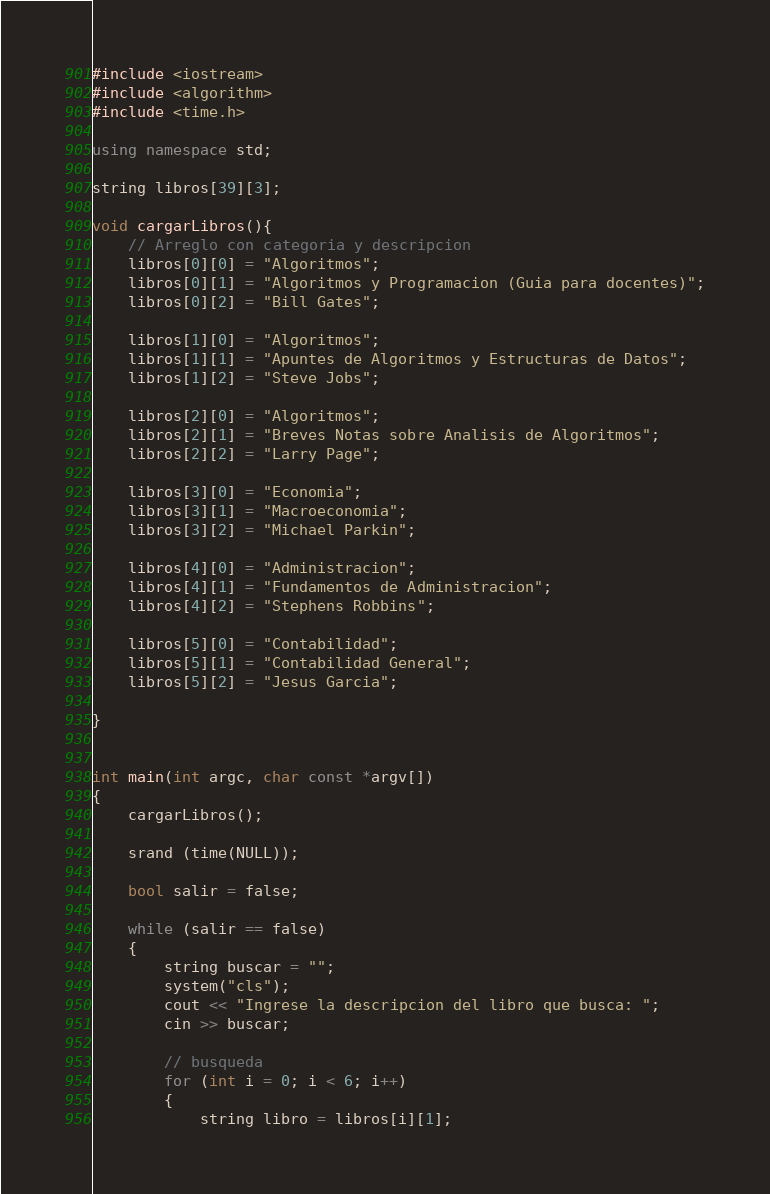<code> <loc_0><loc_0><loc_500><loc_500><_C++_>#include <iostream>
#include <algorithm>
#include <time.h>

using namespace std;

string libros[39][3];

void cargarLibros(){
    // Arreglo con categoria y descripcion
	libros[0][0] = "Algoritmos"; 
    libros[0][1] = "Algoritmos y Programacion (Guia para docentes)";
    libros[0][2] = "Bill Gates";

	libros[1][0] = "Algoritmos"; 
    libros[1][1] = "Apuntes de Algoritmos y Estructuras de Datos";
    libros[1][2] = "Steve Jobs";

	libros[2][0] = "Algoritmos"; 
    libros[2][1] = "Breves Notas sobre Analisis de Algoritmos";
    libros[2][2] = "Larry Page";

	libros[3][0] = "Economia"; 
    libros[3][1] = "Macroeconomia";
    libros[3][2] = "Michael Parkin";

	libros[4][0] = "Administracion"; 
    libros[4][1] = "Fundamentos de Administracion";
    libros[4][2] = "Stephens Robbins";

	libros[5][0] = "Contabilidad"; 
    libros[5][1] = "Contabilidad General";
	libros[5][2] = "Jesus Garcia";

}


int main(int argc, char const *argv[])
{
    cargarLibros();

    srand (time(NULL));
    
    bool salir = false;

    while (salir == false)
    {
        string buscar = "";
        system("cls");
        cout << "Ingrese la descripcion del libro que busca: ";
        cin >> buscar;

        // busqueda
        for (int i = 0; i < 6; i++)
        {
            string libro = libros[i][1];</code> 